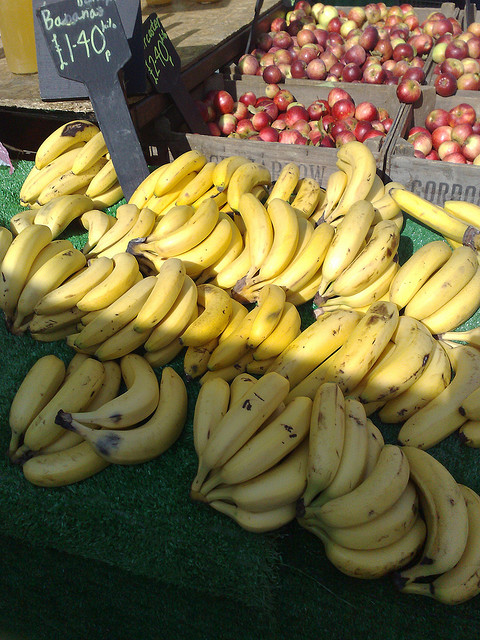How are the bananas displayed for the customers? The bananas are arranged in loose, curved bunches, making it easy for customers to see their quality and select the amount they wish to purchase. Each bunch is connected, allowing for easy separation, and the price is noted on a small sign for customer convenience. 